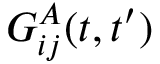Convert formula to latex. <formula><loc_0><loc_0><loc_500><loc_500>G _ { i j } ^ { A } ( t , t ^ { \prime } )</formula> 